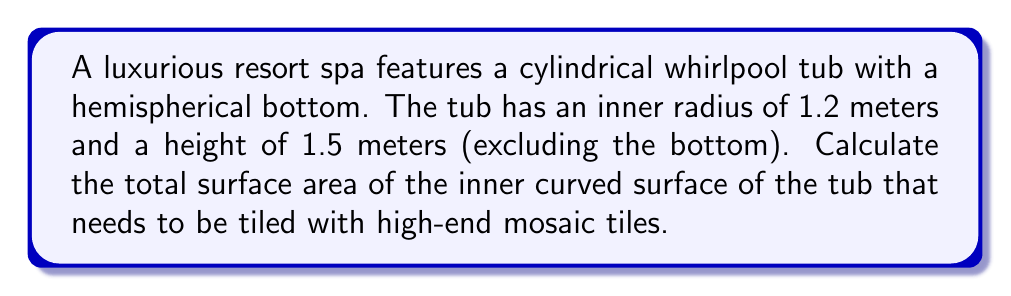Could you help me with this problem? To solve this problem, we need to calculate the surface area of two parts:
1. The cylindrical part of the tub
2. The hemispherical bottom

Step 1: Calculate the surface area of the cylindrical part
The formula for the lateral surface area of a cylinder is:
$$A_{cylinder} = 2\pi rh$$
Where $r$ is the radius and $h$ is the height.

$A_{cylinder} = 2\pi(1.2)(1.5) = 3.6\pi$ m²

Step 2: Calculate the surface area of the hemispherical bottom
The formula for the surface area of a hemisphere is:
$$A_{hemisphere} = 2\pi r^2$$

$A_{hemisphere} = 2\pi(1.2)^2 = 2.88\pi$ m²

Step 3: Sum up the total surface area
Total surface area = $A_{cylinder} + A_{hemisphere}$
$= 3.6\pi + 2.88\pi = 6.48\pi$ m²

Step 4: Simplify and calculate the final answer
$6.48\pi \approx 20.36$ m²
Answer: $20.36$ m² 